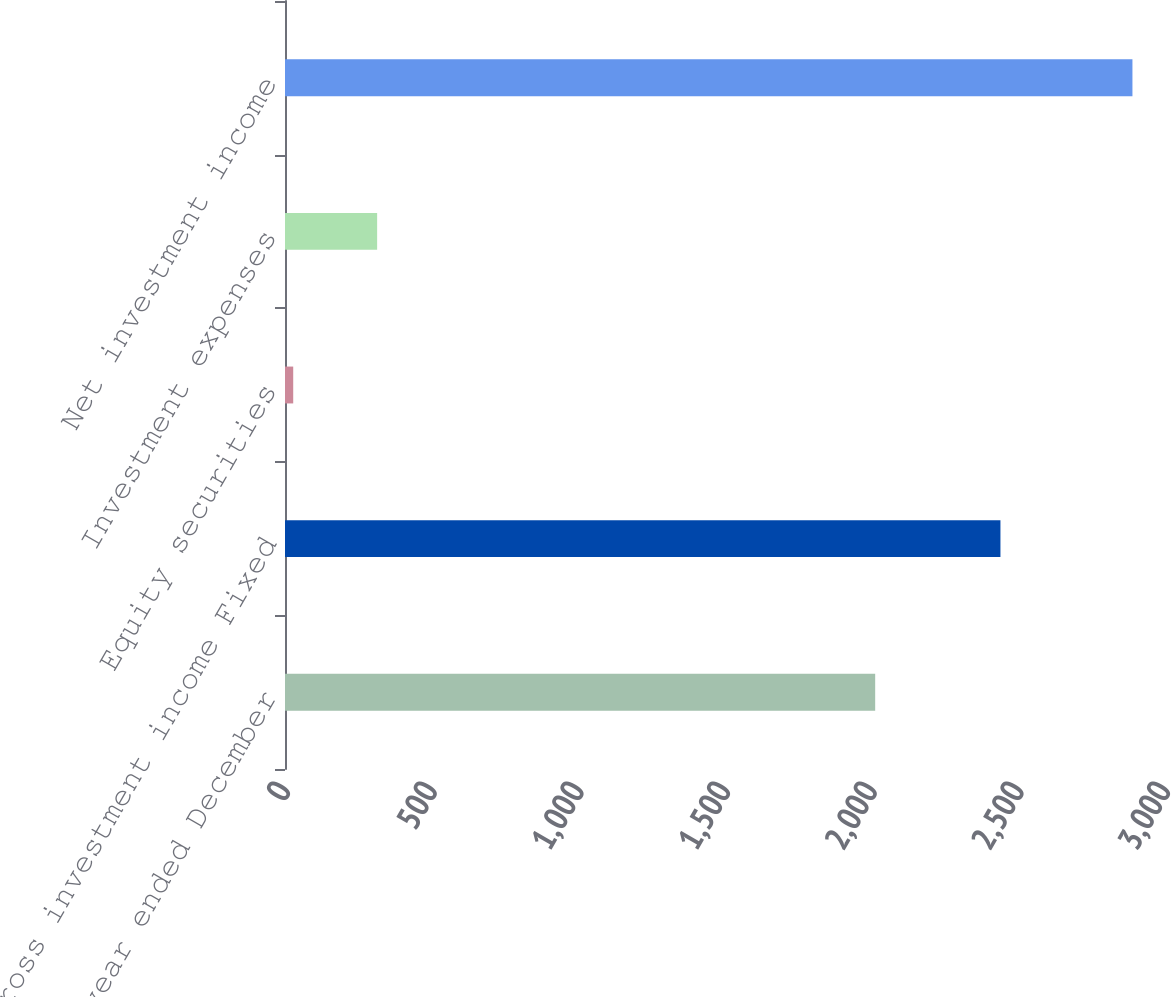<chart> <loc_0><loc_0><loc_500><loc_500><bar_chart><fcel>(for the year ended December<fcel>Gross investment income Fixed<fcel>Equity securities<fcel>Investment expenses<fcel>Net investment income<nl><fcel>2012<fcel>2439<fcel>28<fcel>314.1<fcel>2889<nl></chart> 